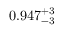<formula> <loc_0><loc_0><loc_500><loc_500>0 . 9 4 7 _ { - 3 } ^ { + 3 }</formula> 